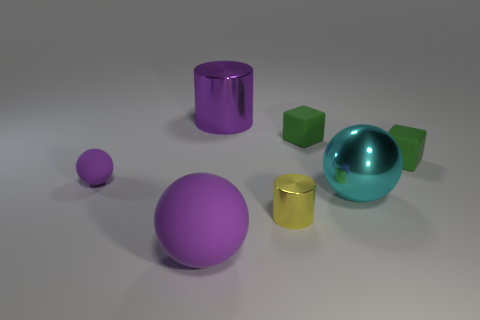Add 1 purple balls. How many objects exist? 8 Subtract all cubes. How many objects are left? 5 Add 2 tiny green rubber blocks. How many tiny green rubber blocks exist? 4 Subtract 0 gray blocks. How many objects are left? 7 Subtract all tiny green matte objects. Subtract all green rubber objects. How many objects are left? 3 Add 2 big balls. How many big balls are left? 4 